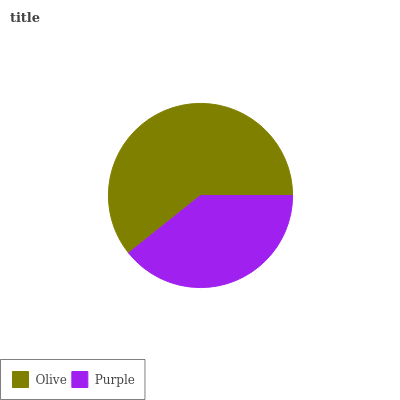Is Purple the minimum?
Answer yes or no. Yes. Is Olive the maximum?
Answer yes or no. Yes. Is Purple the maximum?
Answer yes or no. No. Is Olive greater than Purple?
Answer yes or no. Yes. Is Purple less than Olive?
Answer yes or no. Yes. Is Purple greater than Olive?
Answer yes or no. No. Is Olive less than Purple?
Answer yes or no. No. Is Olive the high median?
Answer yes or no. Yes. Is Purple the low median?
Answer yes or no. Yes. Is Purple the high median?
Answer yes or no. No. Is Olive the low median?
Answer yes or no. No. 